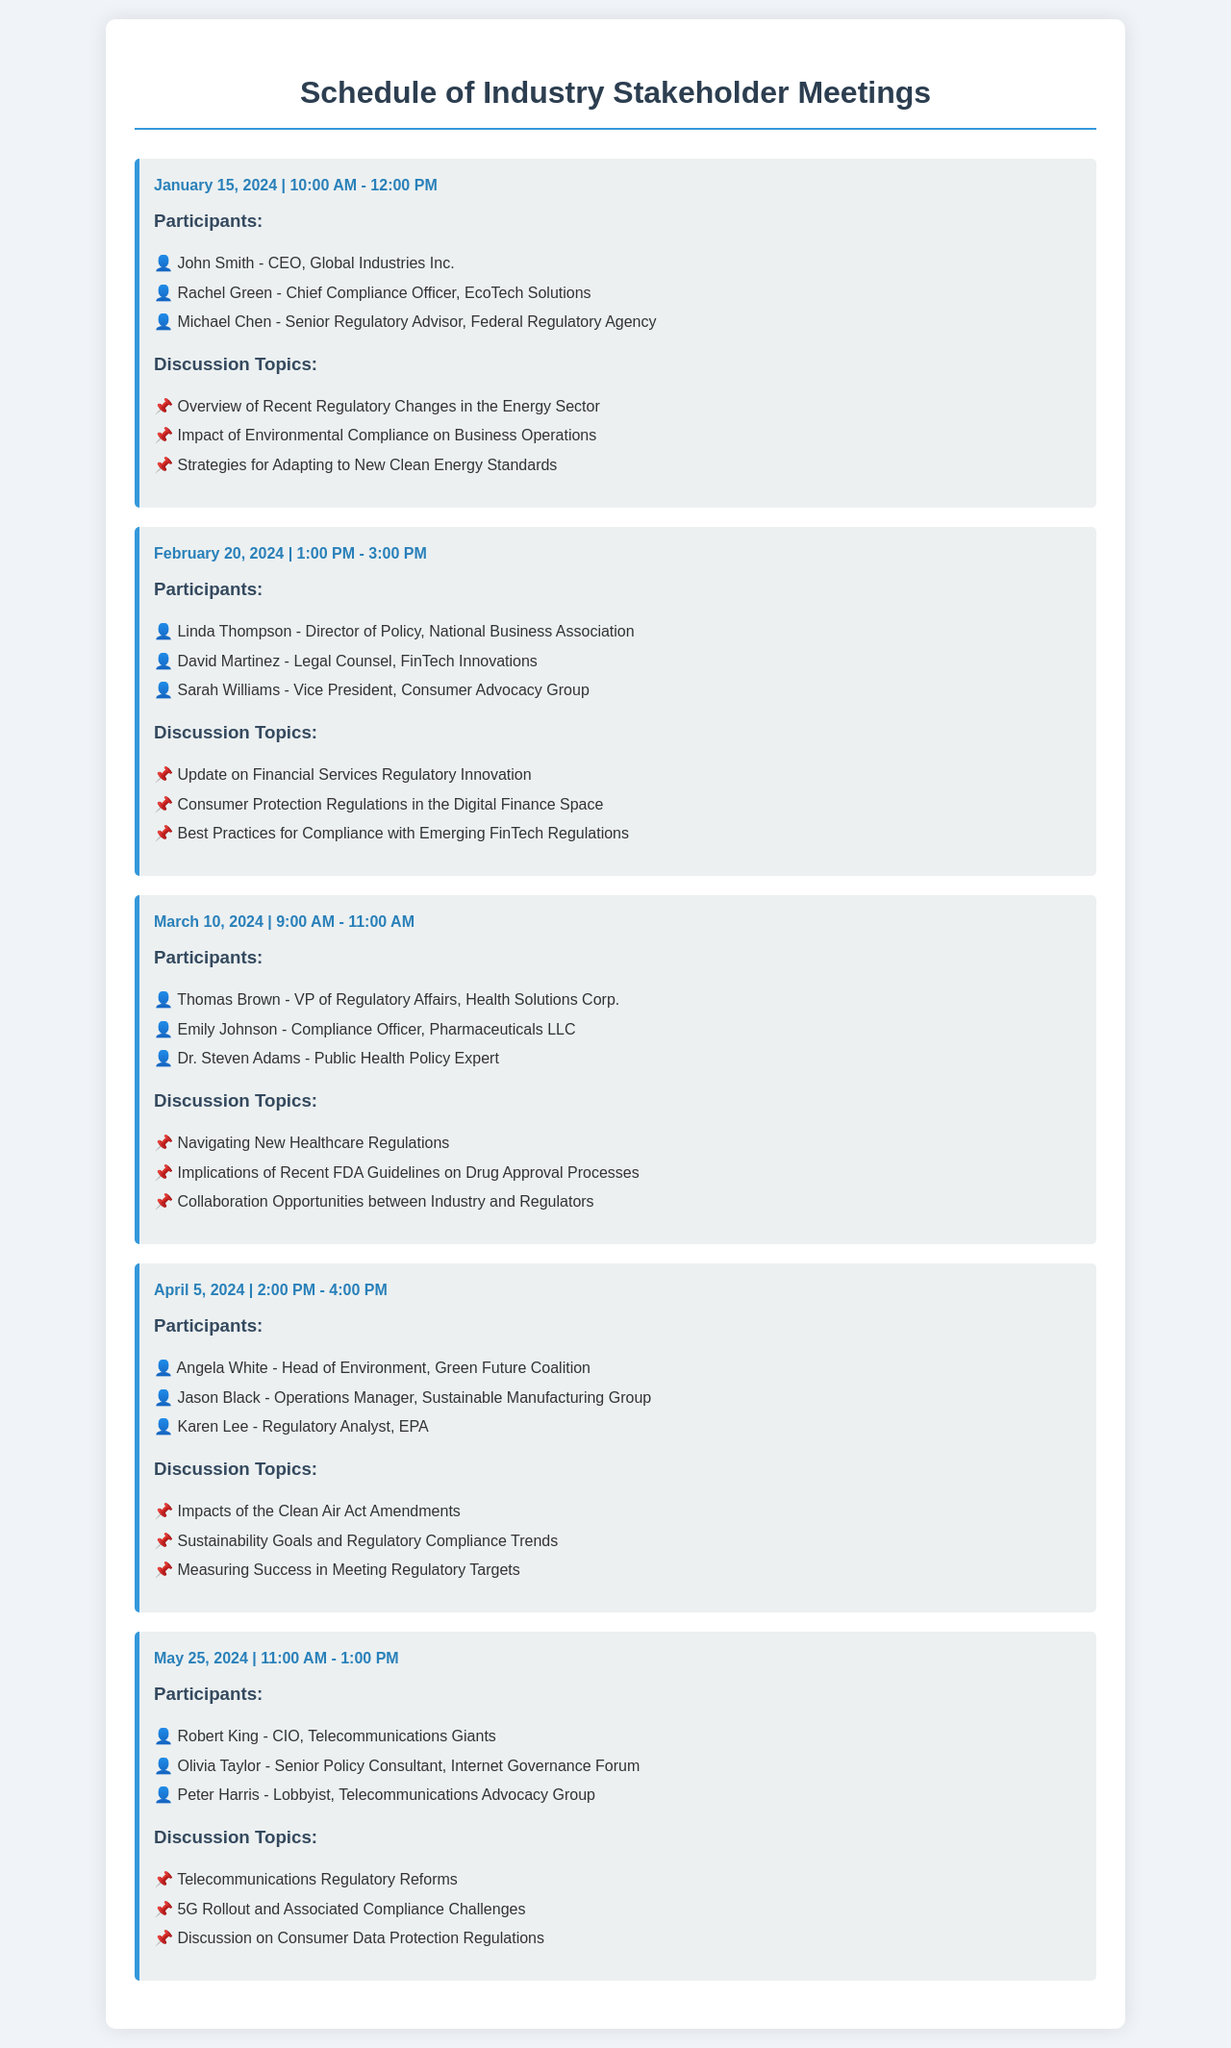What is the date of the first meeting? The first meeting is scheduled for January 15, 2024.
Answer: January 15, 2024 Who is the Chief Compliance Officer participant in the first meeting? Rachel Green holds the title of Chief Compliance Officer in the first meeting.
Answer: Rachel Green What are the discussion topics for the meeting on February 20, 2024? The topics for this meeting include three specific subjects listed under discussion topics.
Answer: Update on Financial Services Regulatory Innovation, Consumer Protection Regulations in the Digital Finance Space, Best Practices for Compliance with Emerging FinTech Regulations How many participants attended the meeting on March 10, 2024? The number of participants at this meeting is determined by listing the individual names.
Answer: 3 Which participant represents the Environmental agency in the April 5, 2024 meeting? The participant from the Environmental agency is indicated in the context of the meeting participants.
Answer: Karen Lee What time does the May 25, 2024 meeting start? The meeting starts at 11:00 AM, as specified in the meeting details.
Answer: 11:00 AM Who is the VP of Regulatory Affairs for the meeting on March 10, 2024? The title and name of the VP of Regulatory Affairs can be found in the participant list of the meeting.
Answer: Thomas Brown What is the primary focus of the discussion in the April 5, 2024 meeting? The main focus involves specific regulatory impacts and compliance trends, which can be confirmed through the discussion topics listed.
Answer: Impacts of the Clean Air Act Amendments 